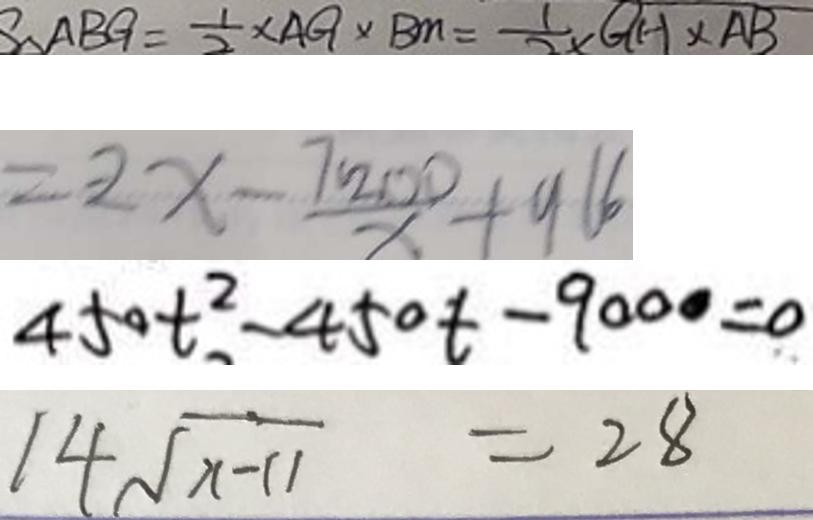Convert formula to latex. <formula><loc_0><loc_0><loc_500><loc_500>S _ { \Delta A B G } = \frac { 1 } { 2 } \times A G \times B M = \frac { 1 } { 2 } Q H \times A B 
 = 2 x - \frac { 7 2 0 0 } { x } + 9 6 6 
 4 5 0 t ^ { 2 } - 4 5 0 t - 9 0 0 0 = 0 
 1 4 \sqrt { x - 1 1 } = 2 8</formula> 